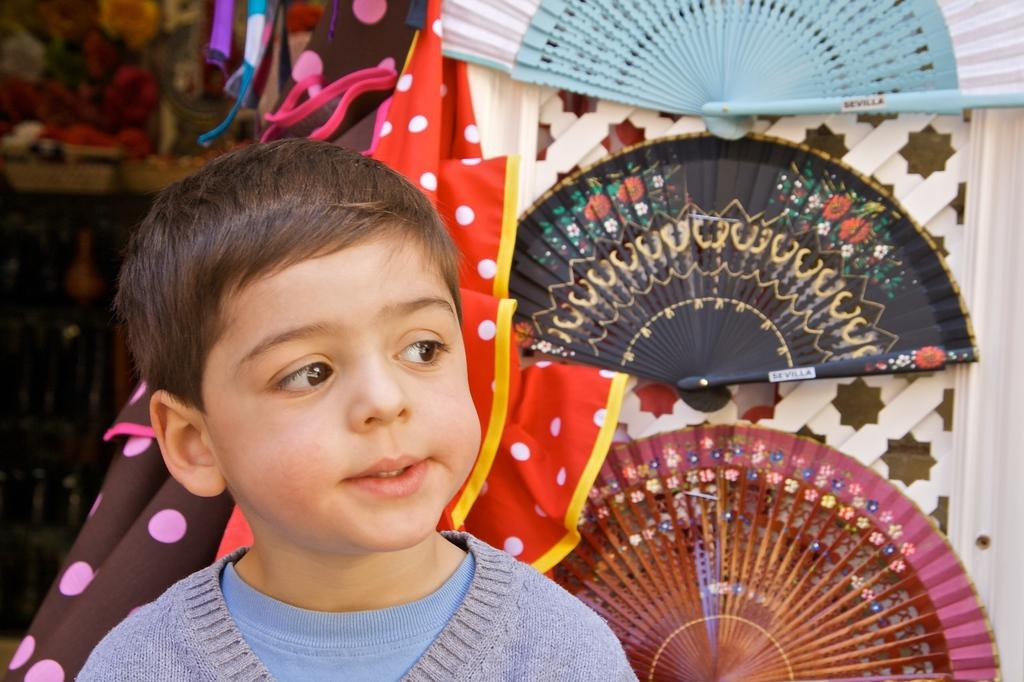What is the main subject of the image? There is a child in the image. What can be observed about the child's attire? The child is wearing clothes. What objects are present in the image besides the child? Hand fans are visible in the image. Can you describe the background of the image? The left side background is slightly blurred. What type of vest is the grandfather wearing in the image? There is no grandfather present in the image, so it is not possible to determine what type of vest they might be wearing. 